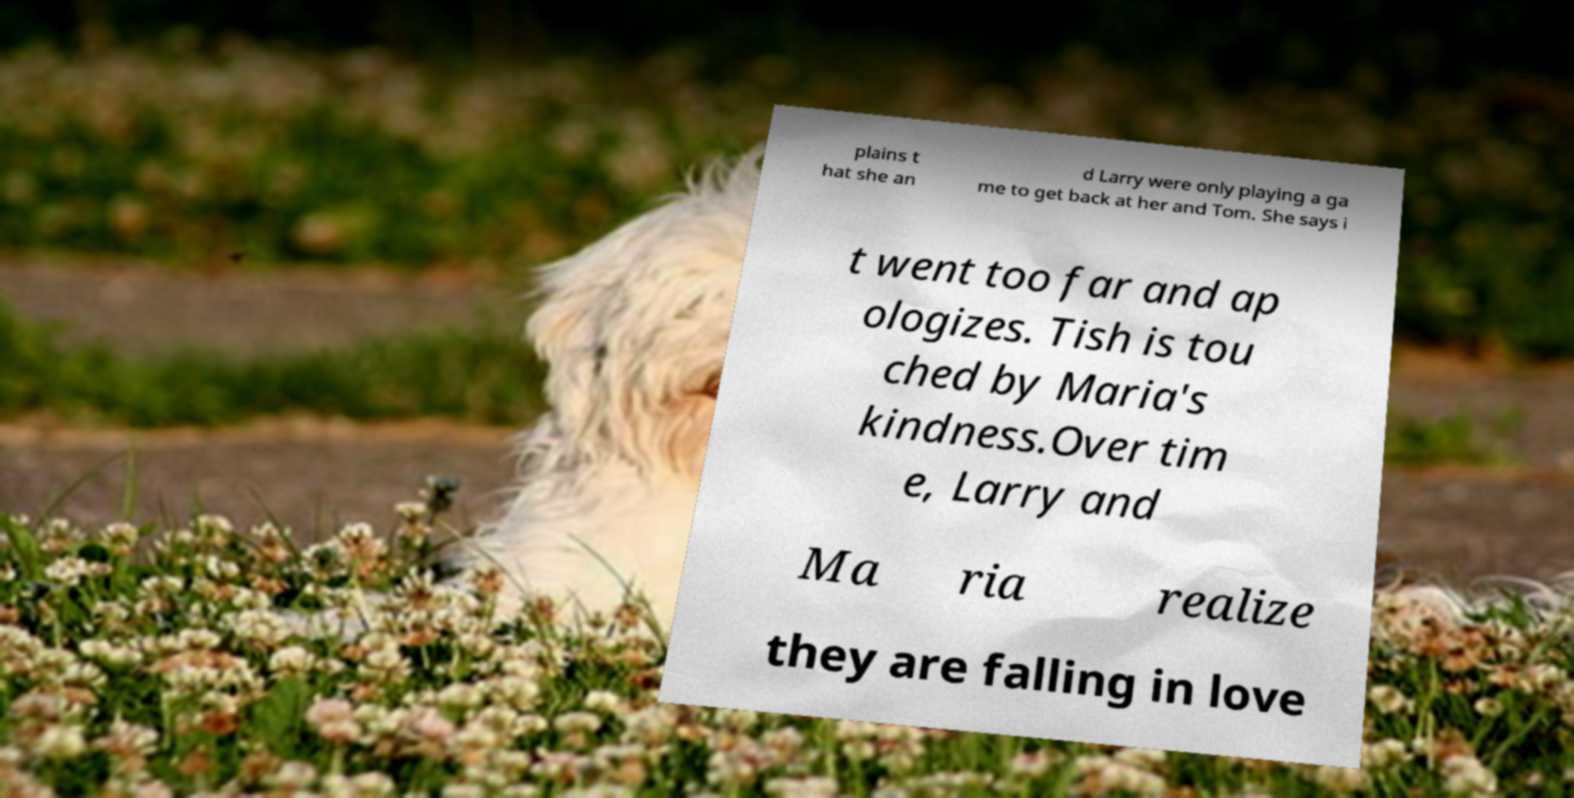For documentation purposes, I need the text within this image transcribed. Could you provide that? plains t hat she an d Larry were only playing a ga me to get back at her and Tom. She says i t went too far and ap ologizes. Tish is tou ched by Maria's kindness.Over tim e, Larry and Ma ria realize they are falling in love 